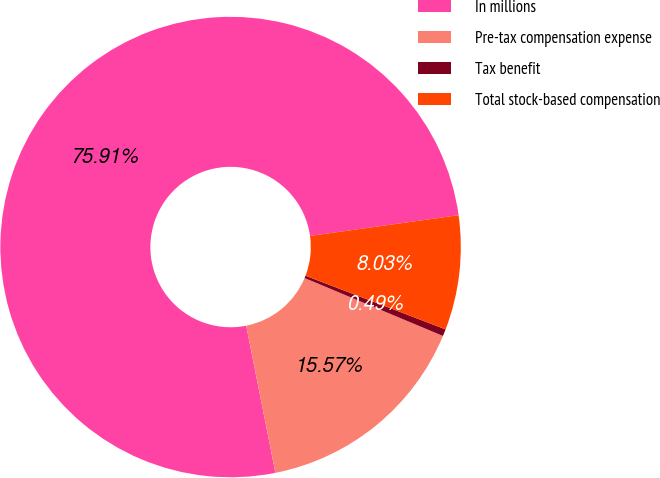Convert chart. <chart><loc_0><loc_0><loc_500><loc_500><pie_chart><fcel>In millions<fcel>Pre-tax compensation expense<fcel>Tax benefit<fcel>Total stock-based compensation<nl><fcel>75.91%<fcel>15.57%<fcel>0.49%<fcel>8.03%<nl></chart> 